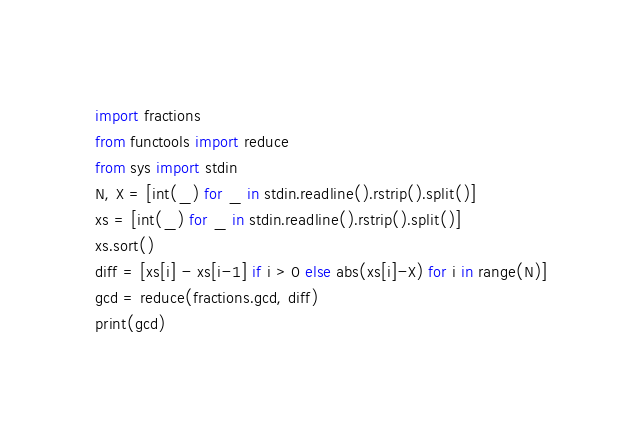<code> <loc_0><loc_0><loc_500><loc_500><_Python_>import fractions
from functools import reduce
from sys import stdin
N, X = [int(_) for _ in stdin.readline().rstrip().split()]
xs = [int(_) for _ in stdin.readline().rstrip().split()]
xs.sort()
diff = [xs[i] - xs[i-1] if i > 0 else abs(xs[i]-X) for i in range(N)]
gcd = reduce(fractions.gcd, diff)
print(gcd)</code> 